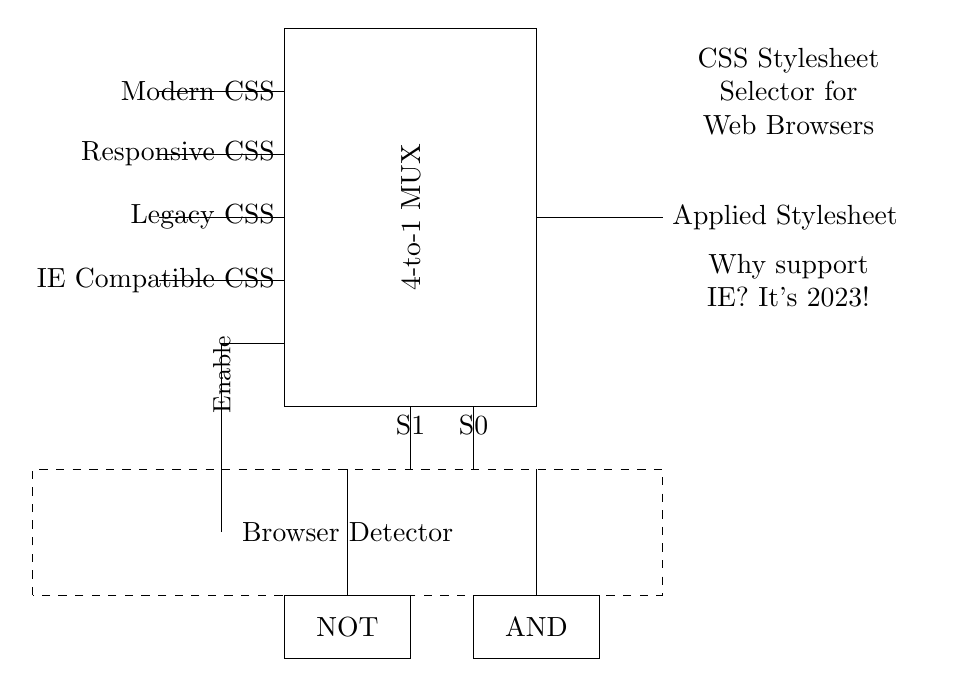What type of multiplexer is represented in this circuit? The circuit shows a 4-to-1 multiplexer, as indicated by the label on the rectangle that states "4-to-1 MUX". This means it takes four input signals and selects one to output based on the selector inputs.
Answer: 4-to-1 MUX What are the inputs of the multiplexer? The inputs are Modern CSS, Responsive CSS, Legacy CSS, and IE Compatible CSS, which are labeled on the left side of the multiplexer. These represent different CSS stylesheets that can be selected for application.
Answer: Modern CSS, Responsive CSS, Legacy CSS, IE Compatible CSS What is the function of the selector inputs S1 and S0? The selector inputs S1 and S0 determine which of the four inputs is routed to the output of the multiplexer by selecting a specific combination of binary values. Each combination corresponds to one of the four inputs.
Answer: Selector inputs What role does the Browser Detector play in this circuit? The Browser Detector monitors the type of browser being used and enables or disables the output of the multiplexer based on the browser's compatibility with the provided CSS stylesheets.
Answer: Determines browser compatibility Which logic gate is used for enabling the output based on the browser detection? A NOT gate is used, as indicated in the circuit diagram. This gate negates a signal to control whether the multiplexer output is enabled or not based on the browser detected.
Answer: NOT gate How many unique CSS stylesheets can this circuit process simultaneously? The circuit can only process one at a time since the multiplexer selects a single input to output at any given moment, despite having four available stylesheets.
Answer: One 